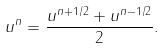<formula> <loc_0><loc_0><loc_500><loc_500>u ^ { n } = \frac { u ^ { n + 1 / 2 } + u ^ { n - 1 / 2 } } { 2 } .</formula> 